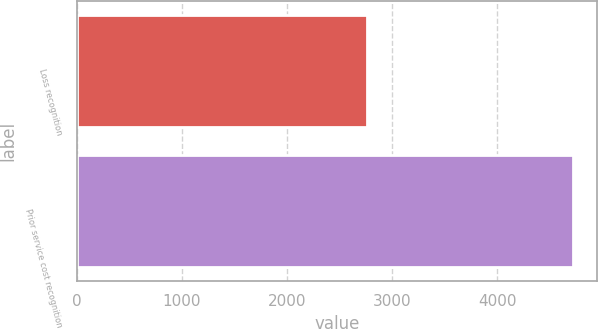Convert chart. <chart><loc_0><loc_0><loc_500><loc_500><bar_chart><fcel>Loss recognition<fcel>Prior service cost recognition<nl><fcel>2763<fcel>4719<nl></chart> 